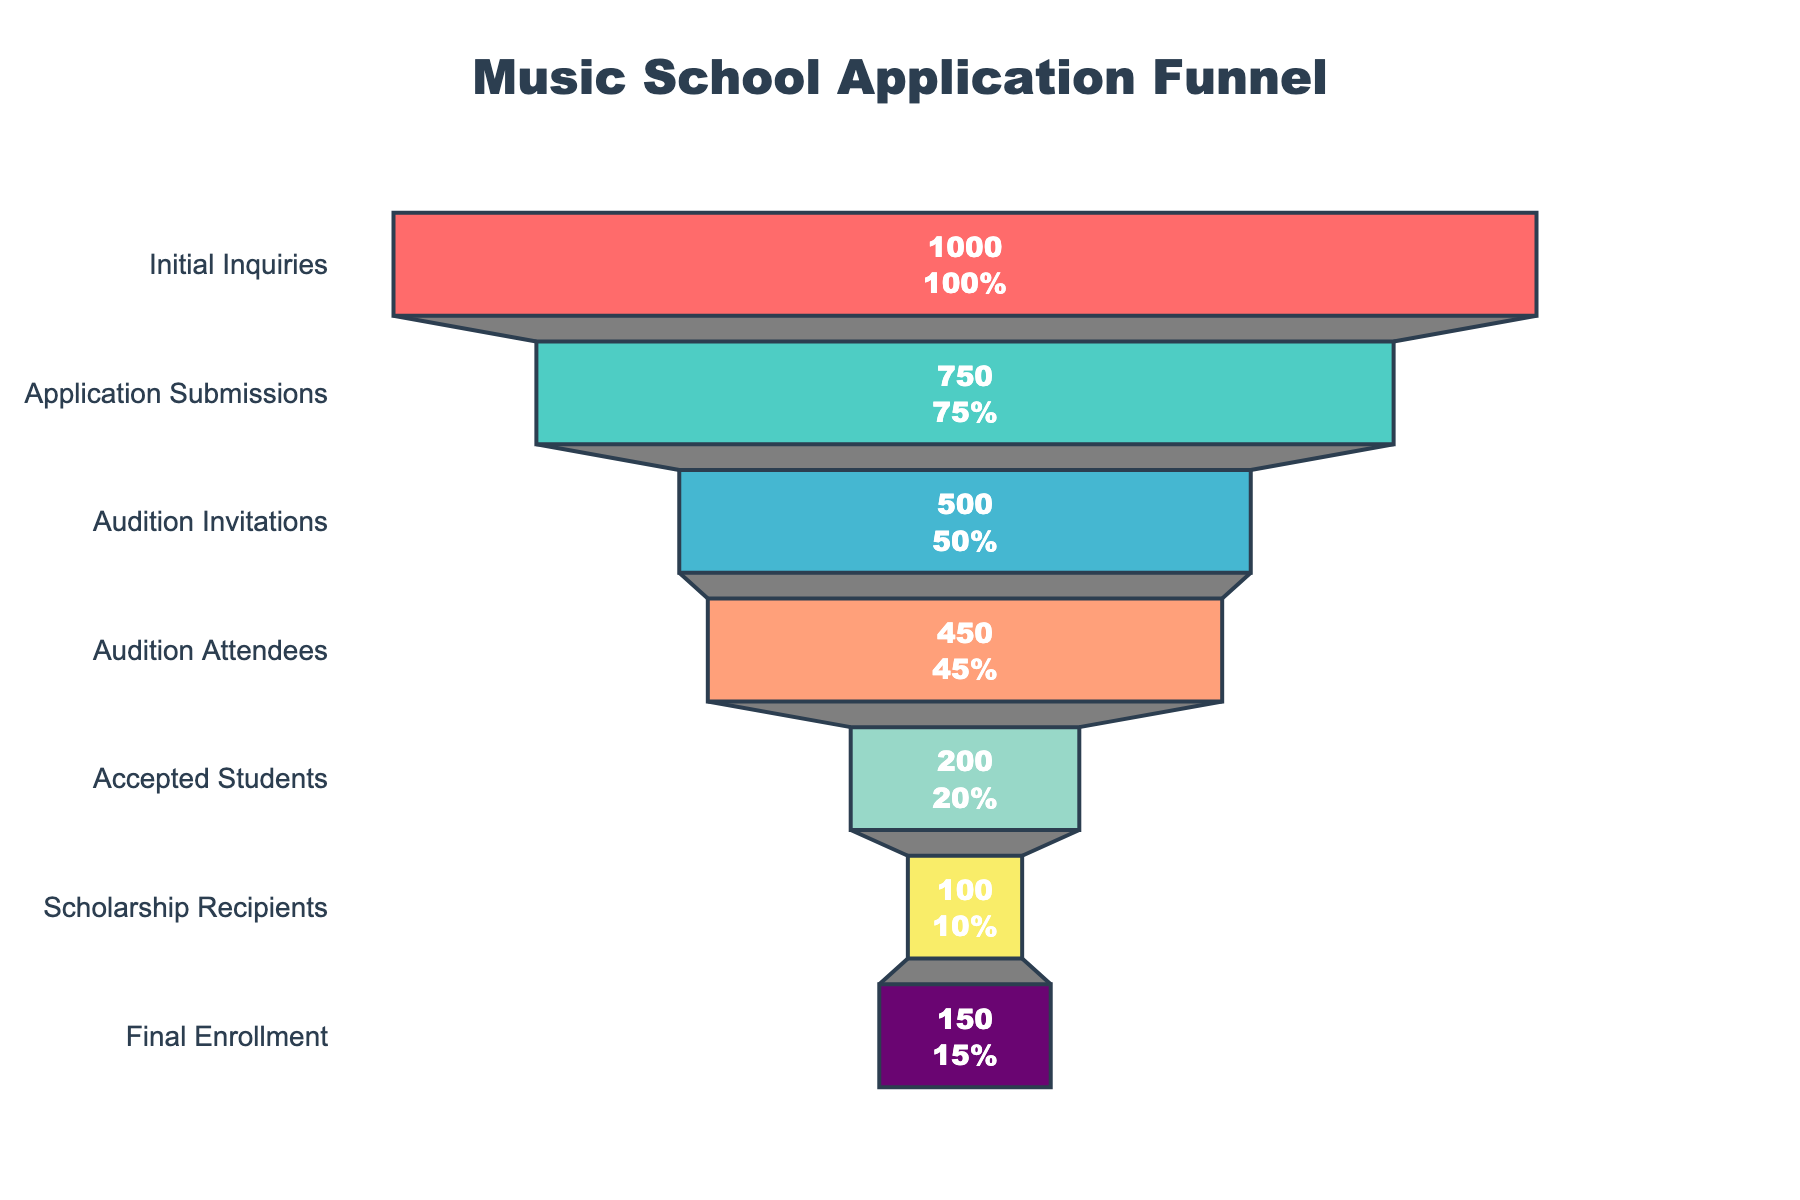What is the title of the funnel chart? The title is displayed at the top and it's mentioned in the layout settings.
Answer: "Music School Application Funnel" How many stages are there in the funnel chart? The stages are listed on the y-axis from top to bottom. By counting them, we find there are 7 stages.
Answer: 7 stages What is the total number of initial inquiries? The initial inquiries are represented by the first value in the chart, which is stated in the top segment.
Answer: 1000 applicants How many students were accepted after the auditions? The segment labeled "Accepted Students" shows the number of students accepted.
Answer: 200 students What is the percentage of students who received scholarships out of those who were accepted? Starting with the "Accepted Students" (200) and comparing it to the number of "Scholarship Recipients" (100), we find the percentage by (100 / 200) * 100 = 50%.
Answer: 50% What is the difference between the number of audition attendees and final enrollment? By subtracting the final enrollment (150) from the audition attendees (450), the difference is 300.
Answer: 300 students How many more applicants submitted their applications than those who attended auditions? Subtract the number of audition attendees (450) from the application submissions (750), the difference is 300.
Answer: 300 applicants What percentage of initial inquiries led to final enrollment? By comparing initial inquiries (1000) to final enrollment (150), we find the percentage by (150 / 1000) * 100 = 15%.
Answer: 15% Which stage had the largest drop in applicants compared to the previous stage? By comparing the drops between each stage, the largest drop is observed between "Audition Attendees" (450) and "Accepted Students" (200), which is a drop of 250.
Answer: Between "Audition Attendees" and "Accepted Students" What is the color of the segment representing "Scholarship Recipients"? The colors are assigned to each stage and can be matched to the "Scholarship Recipients" stage which is colored in a light yellow shade.
Answer: Light yellow 